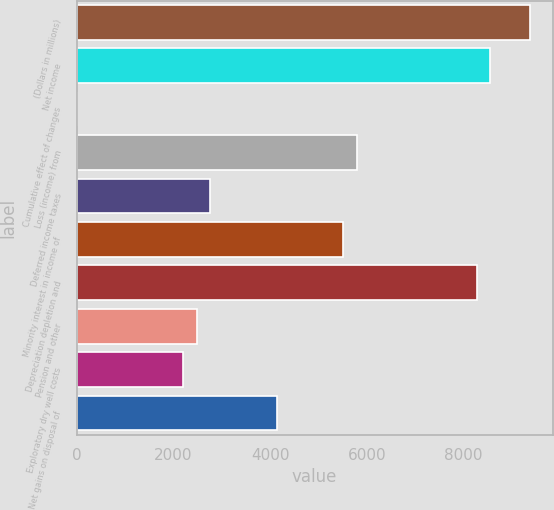Convert chart to OTSL. <chart><loc_0><loc_0><loc_500><loc_500><bar_chart><fcel>(Dollars in millions)<fcel>Net income<fcel>Cumulative effect of changes<fcel>Loss (income) from<fcel>Deferred income taxes<fcel>Minority interest in income of<fcel>Depreciation depletion and<fcel>Pension and other<fcel>Exploratory dry well costs<fcel>Net gains on disposal of<nl><fcel>9377.8<fcel>8550.7<fcel>4<fcel>5793.7<fcel>2761<fcel>5518<fcel>8275<fcel>2485.3<fcel>2209.6<fcel>4139.5<nl></chart> 